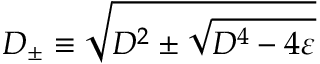Convert formula to latex. <formula><loc_0><loc_0><loc_500><loc_500>D _ { \pm } \equiv \sqrt { D ^ { 2 } \pm \sqrt { D ^ { 4 } - 4 \varepsilon } }</formula> 